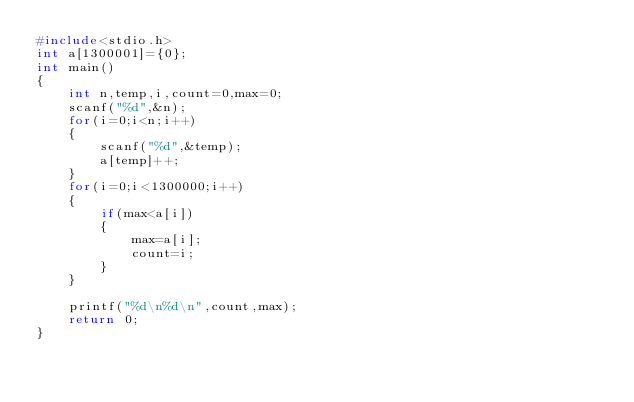Convert code to text. <code><loc_0><loc_0><loc_500><loc_500><_C_>#include<stdio.h>
int a[1300001]={0};
int main()
{
	int n,temp,i,count=0,max=0;
	scanf("%d",&n);
	for(i=0;i<n;i++)
	{
		scanf("%d",&temp);
		a[temp]++;
	}
	for(i=0;i<1300000;i++)
	{
		if(max<a[i])
		{
			max=a[i];
			count=i;
		}
	}
	
	printf("%d\n%d\n",count,max);
	return 0;
} 
</code> 